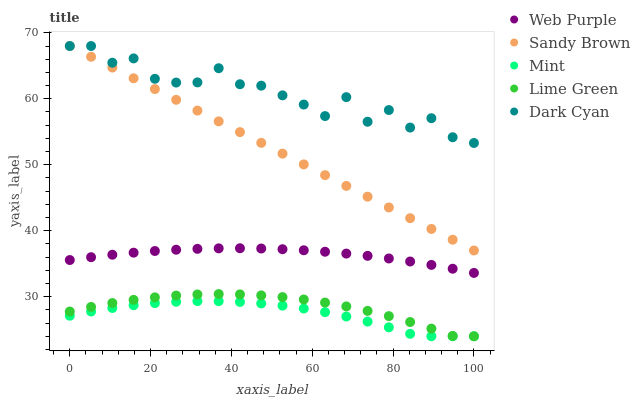Does Mint have the minimum area under the curve?
Answer yes or no. Yes. Does Dark Cyan have the maximum area under the curve?
Answer yes or no. Yes. Does Web Purple have the minimum area under the curve?
Answer yes or no. No. Does Web Purple have the maximum area under the curve?
Answer yes or no. No. Is Sandy Brown the smoothest?
Answer yes or no. Yes. Is Dark Cyan the roughest?
Answer yes or no. Yes. Is Mint the smoothest?
Answer yes or no. No. Is Mint the roughest?
Answer yes or no. No. Does Mint have the lowest value?
Answer yes or no. Yes. Does Web Purple have the lowest value?
Answer yes or no. No. Does Sandy Brown have the highest value?
Answer yes or no. Yes. Does Web Purple have the highest value?
Answer yes or no. No. Is Web Purple less than Sandy Brown?
Answer yes or no. Yes. Is Dark Cyan greater than Web Purple?
Answer yes or no. Yes. Does Mint intersect Lime Green?
Answer yes or no. Yes. Is Mint less than Lime Green?
Answer yes or no. No. Is Mint greater than Lime Green?
Answer yes or no. No. Does Web Purple intersect Sandy Brown?
Answer yes or no. No. 